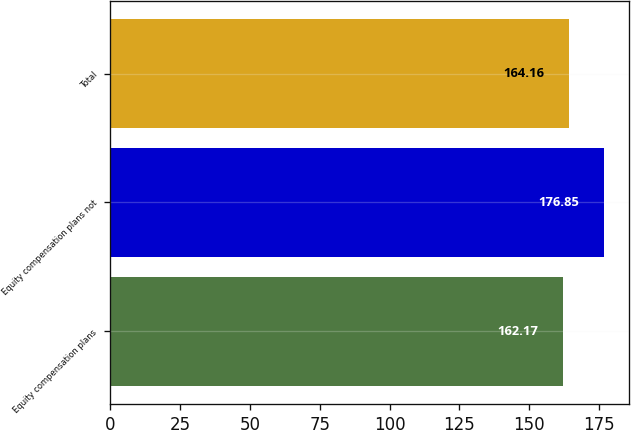Convert chart. <chart><loc_0><loc_0><loc_500><loc_500><bar_chart><fcel>Equity compensation plans<fcel>Equity compensation plans not<fcel>Total<nl><fcel>162.17<fcel>176.85<fcel>164.16<nl></chart> 